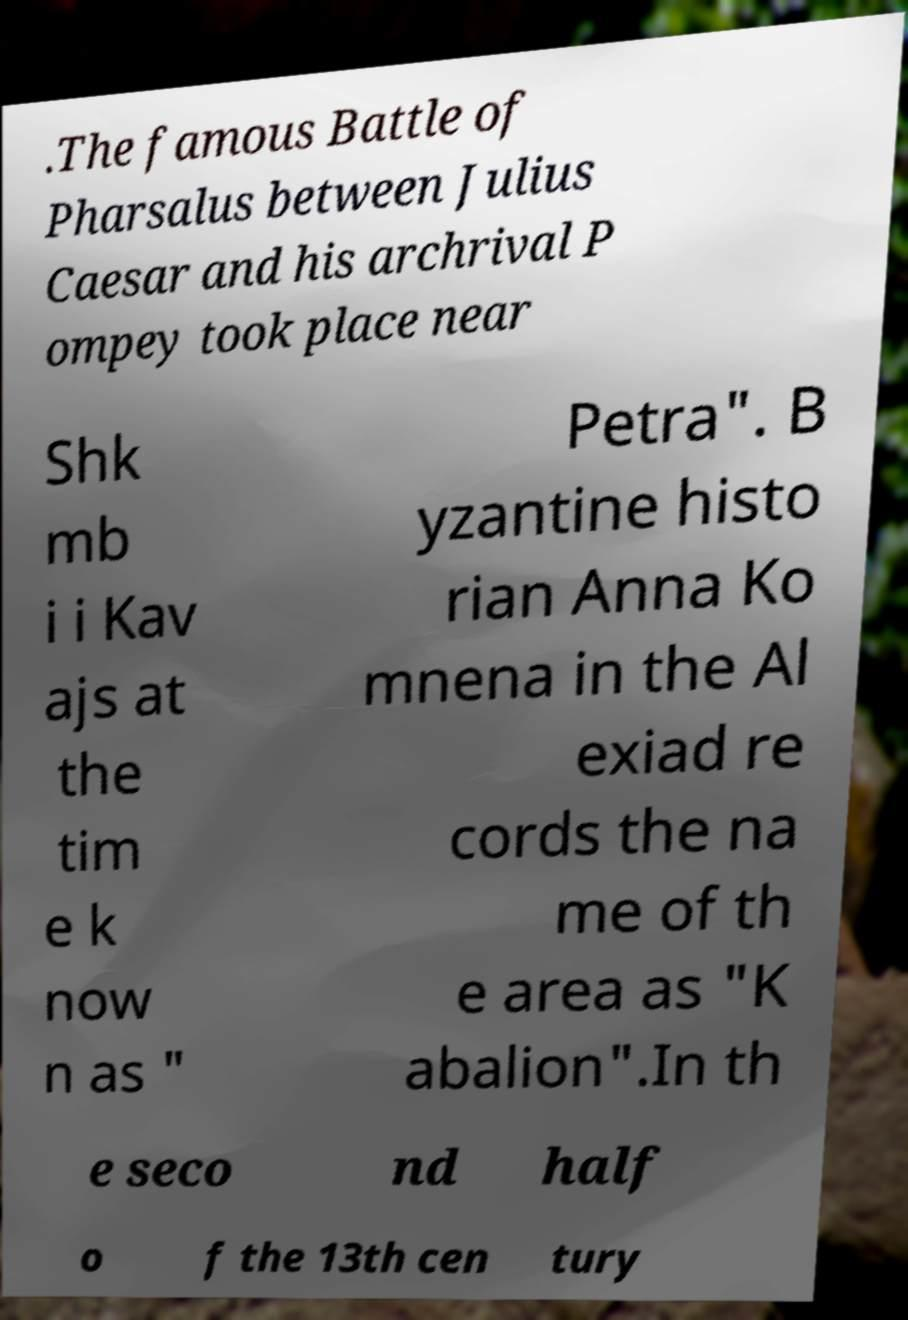There's text embedded in this image that I need extracted. Can you transcribe it verbatim? .The famous Battle of Pharsalus between Julius Caesar and his archrival P ompey took place near Shk mb i i Kav ajs at the tim e k now n as " Petra". B yzantine histo rian Anna Ko mnena in the Al exiad re cords the na me of th e area as "K abalion".In th e seco nd half o f the 13th cen tury 